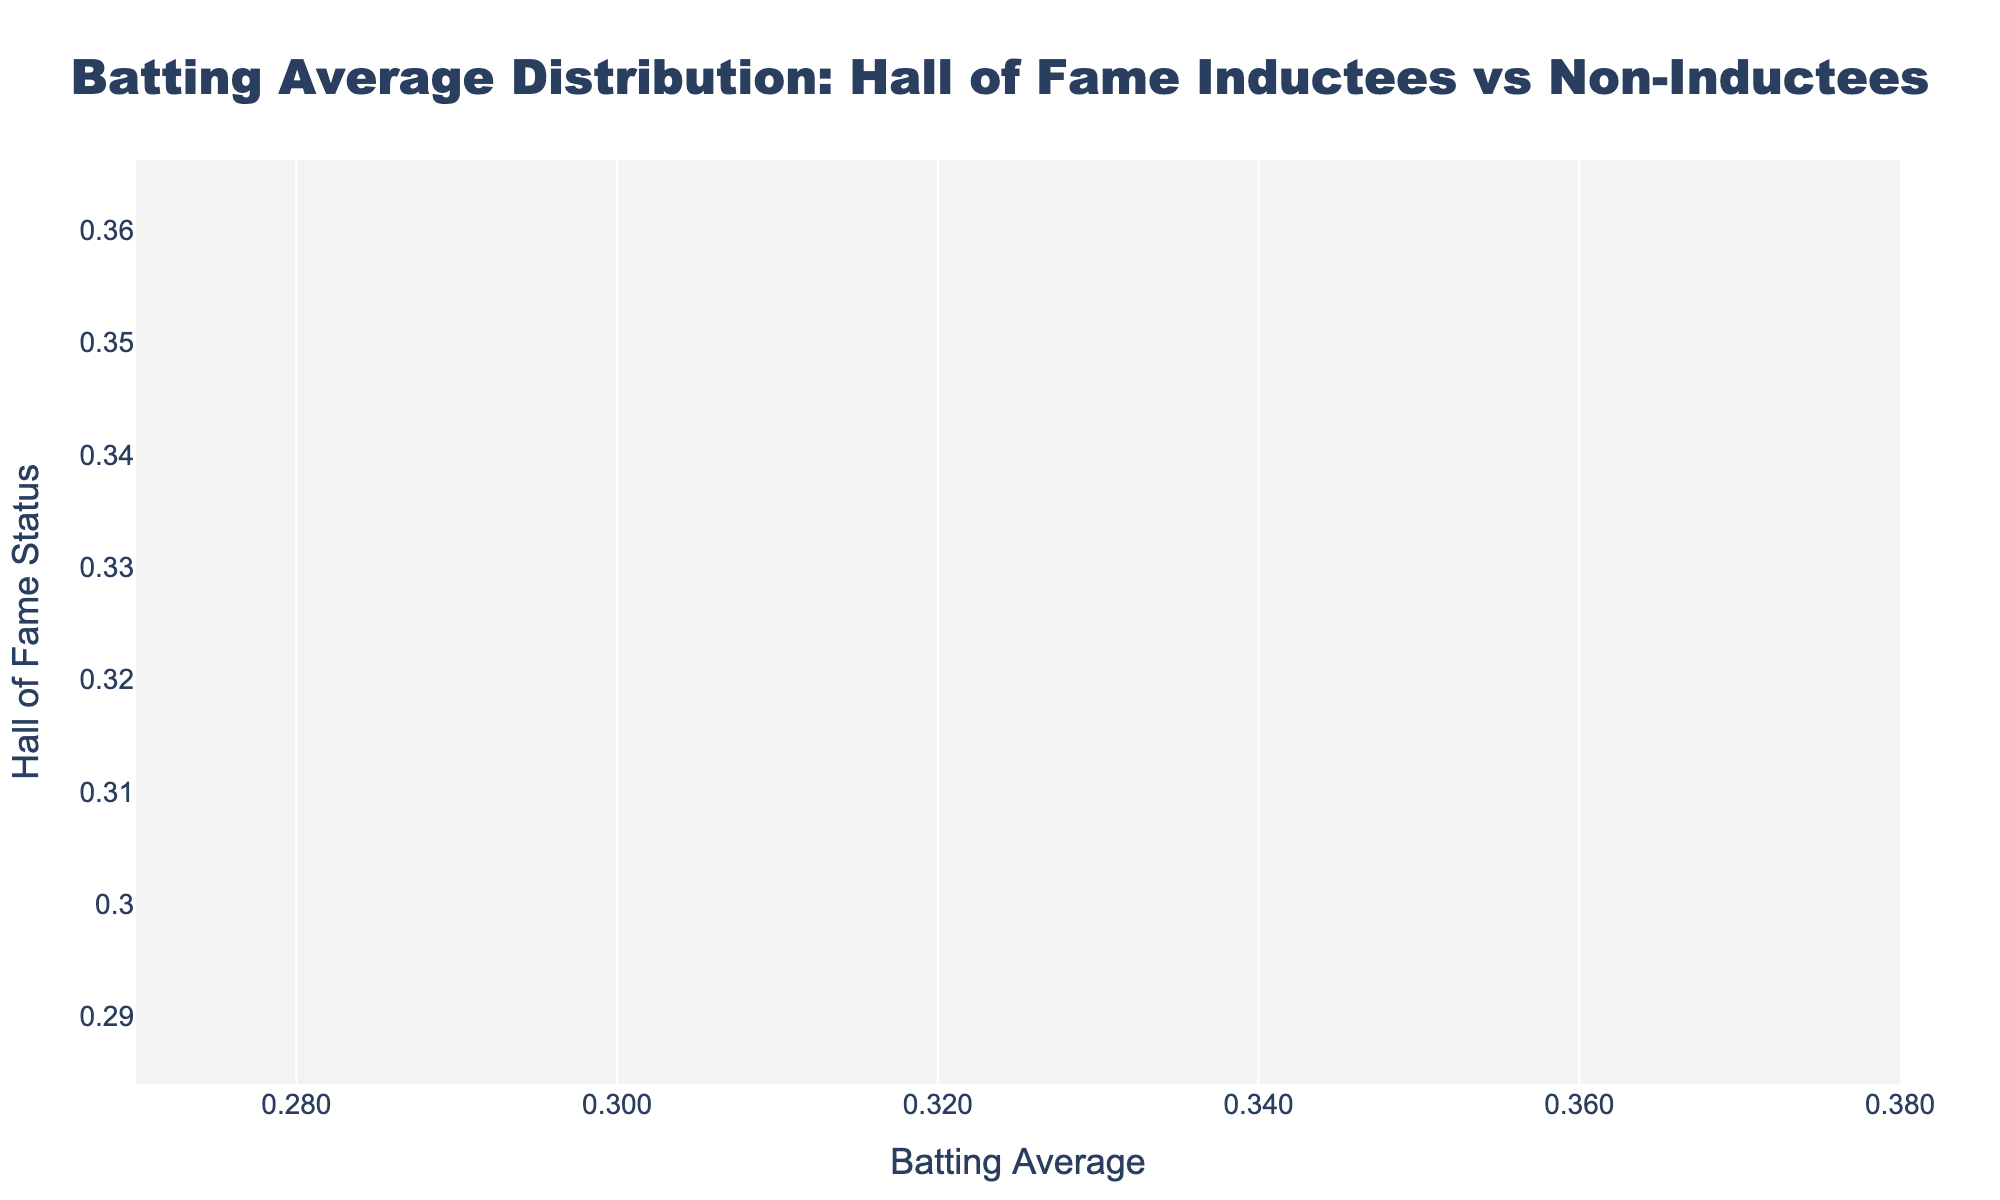What is the title of the plot? The title of the plot is usually located at the top. In this case, it states "Batting Average Distribution: Hall of Fame Inductees vs Non-Inductees".
Answer: Batting Average Distribution: Hall of Fame Inductees vs Non-Inductees What is the range of the x-axis? By checking the x-axis labels, the range is from approximately 0.27 to 0.38, with tick intervals formatted to three decimal places.
Answer: 0.27 to 0.38 How many Hall of Fame inductees have a batting average above 0.33? Look at the positive density plot (usually on the right). Count the individual points above the 0.33 mark. There are 6 such points.
Answer: 6 Which group, inducted or not inducted, has a higher peak in the density plot? Compare the heights of the curves. The group with the taller density plot has a higher peak, which is the 'Inducted' group.
Answer: Inducted What is the median batting average for the inducted players? There are 14 inducted players. To find the median, look for the 7th and 8th highest averages: They are 0.328 and 0.328. The median is (0.328 + 0.328) / 2.
Answer: 0.328 Who has the highest batting average among the non-inducted players? Look at the individual points for non-inducted players on the horizontal axis and find the highest one. Pete Rose has the highest batting average among them with 0.303.
Answer: Pete Rose What's the difference between the highest batting average of an inducted player and a non-inductee? The highest batting average among inducted players is 0.366 (Ty Cobb), and among non-inducted is 0.311 (Ichiro Suzuki). Calculate the difference: 0.366 - 0.311 = 0.055.
Answer: 0.055 Which player has a batting average of 0.311? Check the data points hovering over the scatter plot points for both groups. The name 'Ichiro Suzuki' appears with a batting average of 0.311.
Answer: Ichiro Suzuki Are there any players with exactly the same batting average? Compare individual points on the scatter plots. Players like Wade Boggs and Rod Carew both have an average of 0.328.
Answer: Yes Is there a higher concentration of inducted players' batting averages on the higher end compared to non-inducted players? Examine the density plots' width and peaks at the higher batting average values (right end). Inducted players' density plot has a prominent peak near 0.33–0.36, indicating a higher concentration of players in that range.
Answer: Yes 